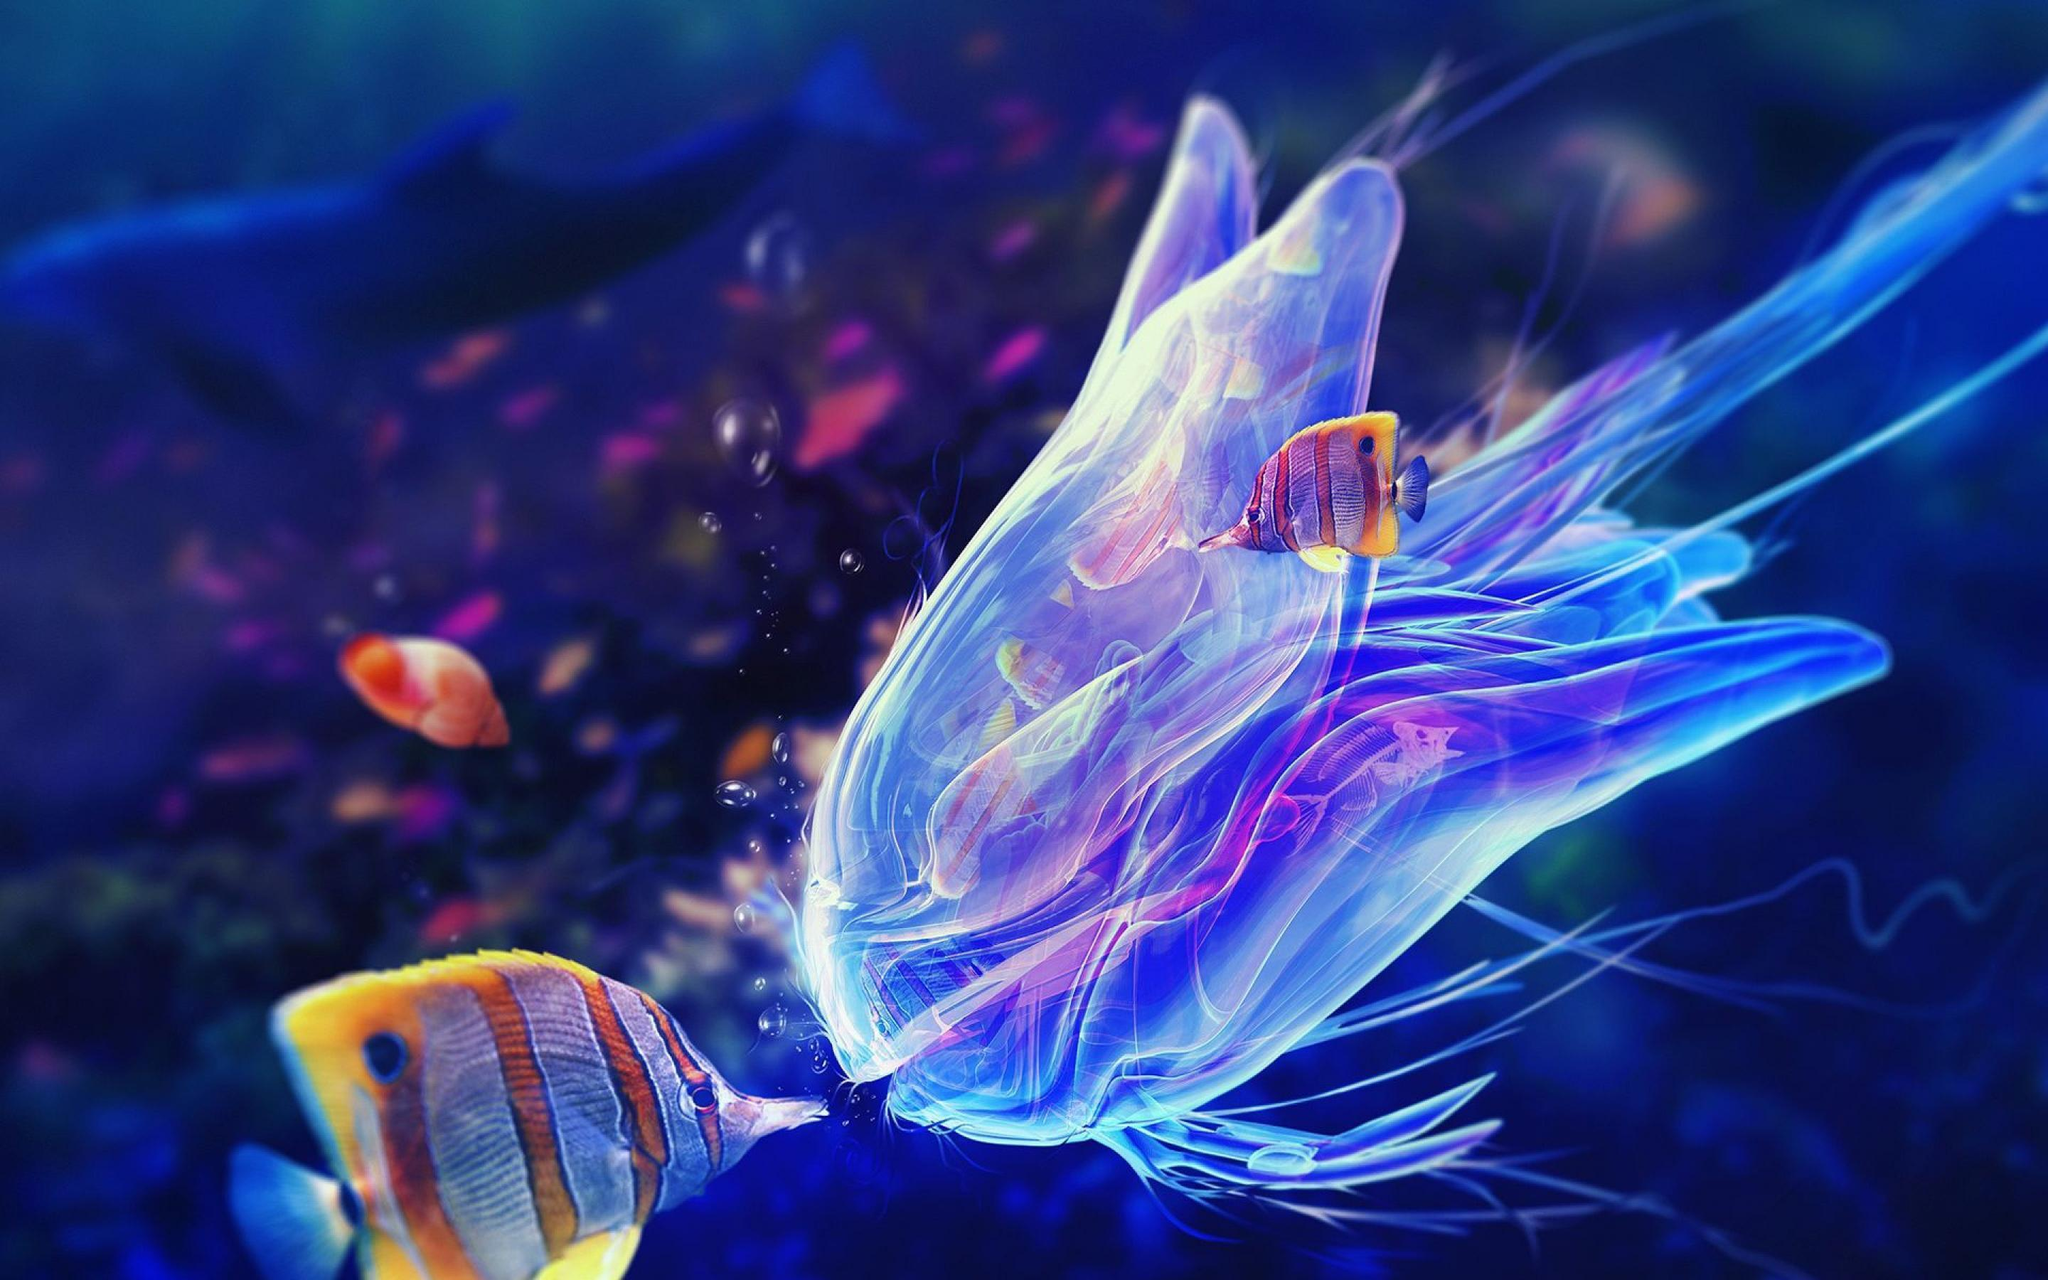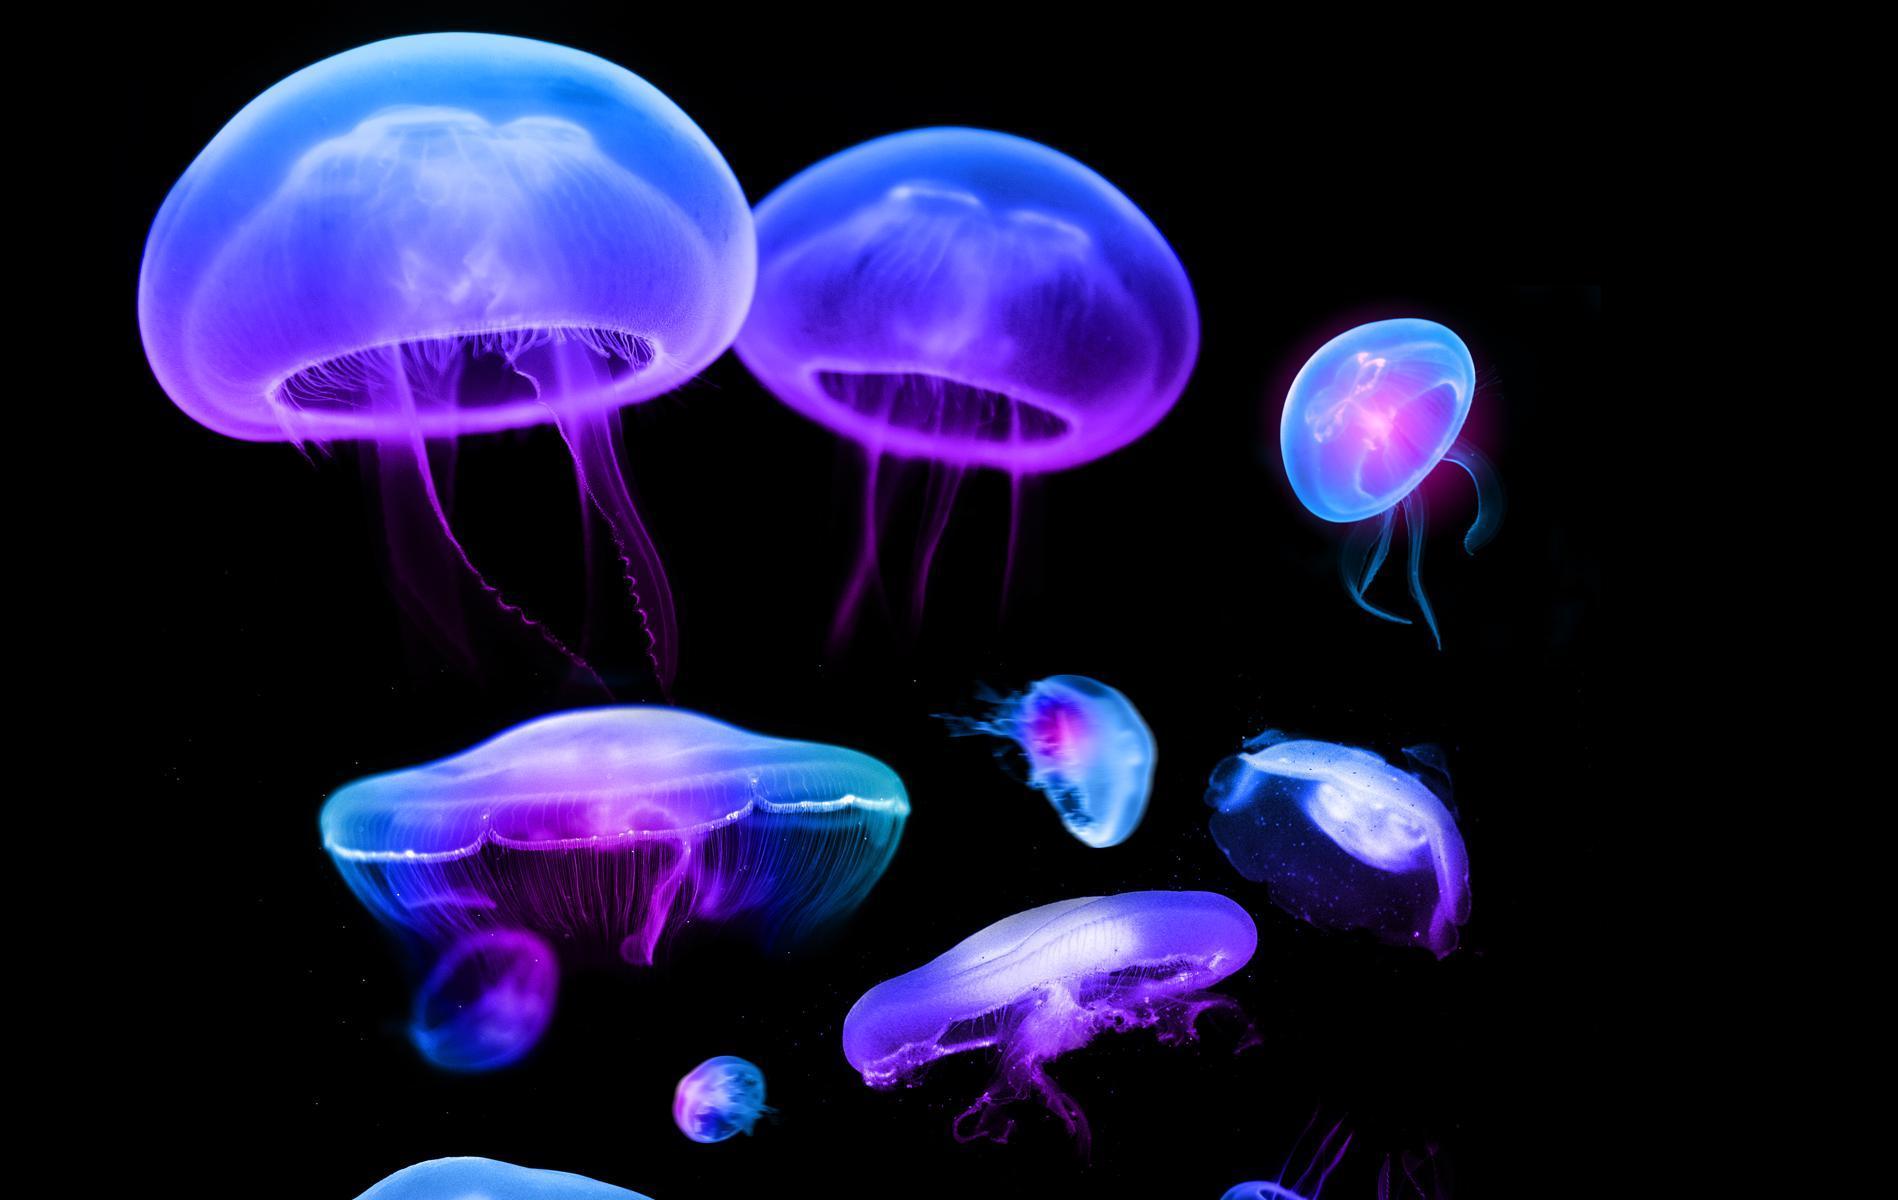The first image is the image on the left, the second image is the image on the right. Analyze the images presented: Is the assertion "There are no more than 5 jellyfish in the image on the right." valid? Answer yes or no. No. 